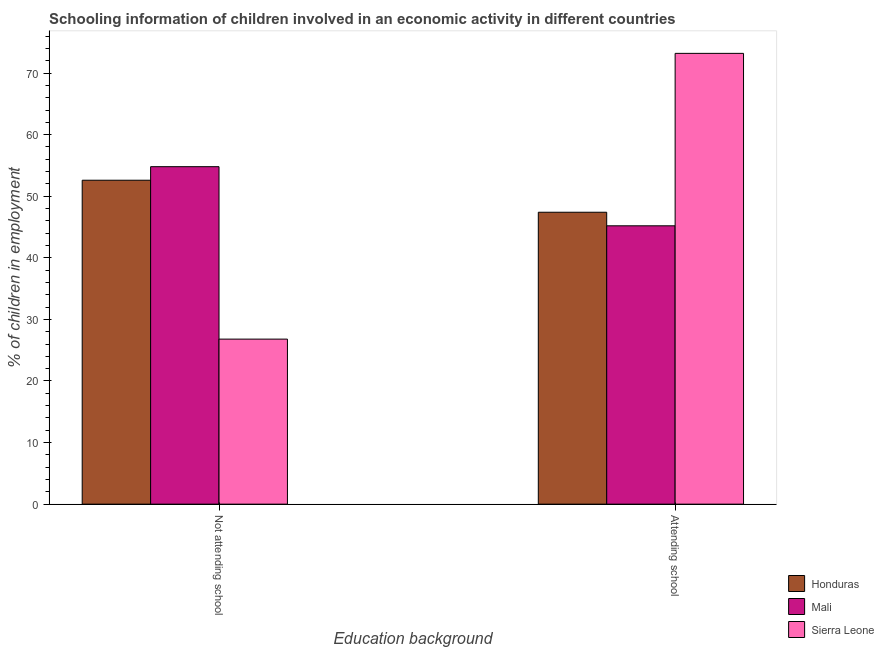How many bars are there on the 2nd tick from the right?
Your response must be concise. 3. What is the label of the 1st group of bars from the left?
Keep it short and to the point. Not attending school. What is the percentage of employed children who are not attending school in Mali?
Offer a very short reply. 54.8. Across all countries, what is the maximum percentage of employed children who are not attending school?
Give a very brief answer. 54.8. Across all countries, what is the minimum percentage of employed children who are attending school?
Give a very brief answer. 45.2. In which country was the percentage of employed children who are not attending school maximum?
Offer a terse response. Mali. In which country was the percentage of employed children who are attending school minimum?
Your answer should be compact. Mali. What is the total percentage of employed children who are not attending school in the graph?
Provide a succinct answer. 134.2. What is the difference between the percentage of employed children who are attending school in Sierra Leone and that in Honduras?
Keep it short and to the point. 25.8. What is the difference between the percentage of employed children who are attending school in Honduras and the percentage of employed children who are not attending school in Sierra Leone?
Give a very brief answer. 20.6. What is the average percentage of employed children who are attending school per country?
Your answer should be very brief. 55.27. What is the difference between the percentage of employed children who are not attending school and percentage of employed children who are attending school in Mali?
Your answer should be very brief. 9.6. In how many countries, is the percentage of employed children who are attending school greater than 22 %?
Keep it short and to the point. 3. What is the ratio of the percentage of employed children who are not attending school in Mali to that in Honduras?
Ensure brevity in your answer.  1.04. Is the percentage of employed children who are not attending school in Sierra Leone less than that in Honduras?
Your answer should be very brief. Yes. What does the 2nd bar from the left in Attending school represents?
Give a very brief answer. Mali. What does the 3rd bar from the right in Attending school represents?
Your answer should be compact. Honduras. How many countries are there in the graph?
Your answer should be very brief. 3. Does the graph contain grids?
Your answer should be compact. No. How many legend labels are there?
Offer a terse response. 3. How are the legend labels stacked?
Provide a succinct answer. Vertical. What is the title of the graph?
Offer a very short reply. Schooling information of children involved in an economic activity in different countries. What is the label or title of the X-axis?
Keep it short and to the point. Education background. What is the label or title of the Y-axis?
Ensure brevity in your answer.  % of children in employment. What is the % of children in employment in Honduras in Not attending school?
Your answer should be very brief. 52.6. What is the % of children in employment in Mali in Not attending school?
Offer a terse response. 54.8. What is the % of children in employment of Sierra Leone in Not attending school?
Provide a succinct answer. 26.8. What is the % of children in employment of Honduras in Attending school?
Provide a succinct answer. 47.4. What is the % of children in employment of Mali in Attending school?
Your response must be concise. 45.2. What is the % of children in employment in Sierra Leone in Attending school?
Your answer should be compact. 73.2. Across all Education background, what is the maximum % of children in employment in Honduras?
Give a very brief answer. 52.6. Across all Education background, what is the maximum % of children in employment of Mali?
Give a very brief answer. 54.8. Across all Education background, what is the maximum % of children in employment of Sierra Leone?
Offer a very short reply. 73.2. Across all Education background, what is the minimum % of children in employment in Honduras?
Ensure brevity in your answer.  47.4. Across all Education background, what is the minimum % of children in employment in Mali?
Offer a very short reply. 45.2. Across all Education background, what is the minimum % of children in employment of Sierra Leone?
Offer a terse response. 26.8. What is the difference between the % of children in employment of Sierra Leone in Not attending school and that in Attending school?
Provide a succinct answer. -46.4. What is the difference between the % of children in employment of Honduras in Not attending school and the % of children in employment of Sierra Leone in Attending school?
Your answer should be compact. -20.6. What is the difference between the % of children in employment of Mali in Not attending school and the % of children in employment of Sierra Leone in Attending school?
Provide a short and direct response. -18.4. What is the average % of children in employment of Honduras per Education background?
Provide a short and direct response. 50. What is the average % of children in employment in Mali per Education background?
Your answer should be compact. 50. What is the average % of children in employment of Sierra Leone per Education background?
Offer a very short reply. 50. What is the difference between the % of children in employment in Honduras and % of children in employment in Mali in Not attending school?
Provide a succinct answer. -2.2. What is the difference between the % of children in employment of Honduras and % of children in employment of Sierra Leone in Not attending school?
Your answer should be compact. 25.8. What is the difference between the % of children in employment of Mali and % of children in employment of Sierra Leone in Not attending school?
Give a very brief answer. 28. What is the difference between the % of children in employment in Honduras and % of children in employment in Sierra Leone in Attending school?
Give a very brief answer. -25.8. What is the difference between the % of children in employment of Mali and % of children in employment of Sierra Leone in Attending school?
Offer a terse response. -28. What is the ratio of the % of children in employment in Honduras in Not attending school to that in Attending school?
Offer a terse response. 1.11. What is the ratio of the % of children in employment in Mali in Not attending school to that in Attending school?
Your answer should be very brief. 1.21. What is the ratio of the % of children in employment in Sierra Leone in Not attending school to that in Attending school?
Give a very brief answer. 0.37. What is the difference between the highest and the second highest % of children in employment in Honduras?
Ensure brevity in your answer.  5.2. What is the difference between the highest and the second highest % of children in employment in Mali?
Your answer should be very brief. 9.6. What is the difference between the highest and the second highest % of children in employment in Sierra Leone?
Provide a succinct answer. 46.4. What is the difference between the highest and the lowest % of children in employment in Mali?
Provide a succinct answer. 9.6. What is the difference between the highest and the lowest % of children in employment in Sierra Leone?
Give a very brief answer. 46.4. 